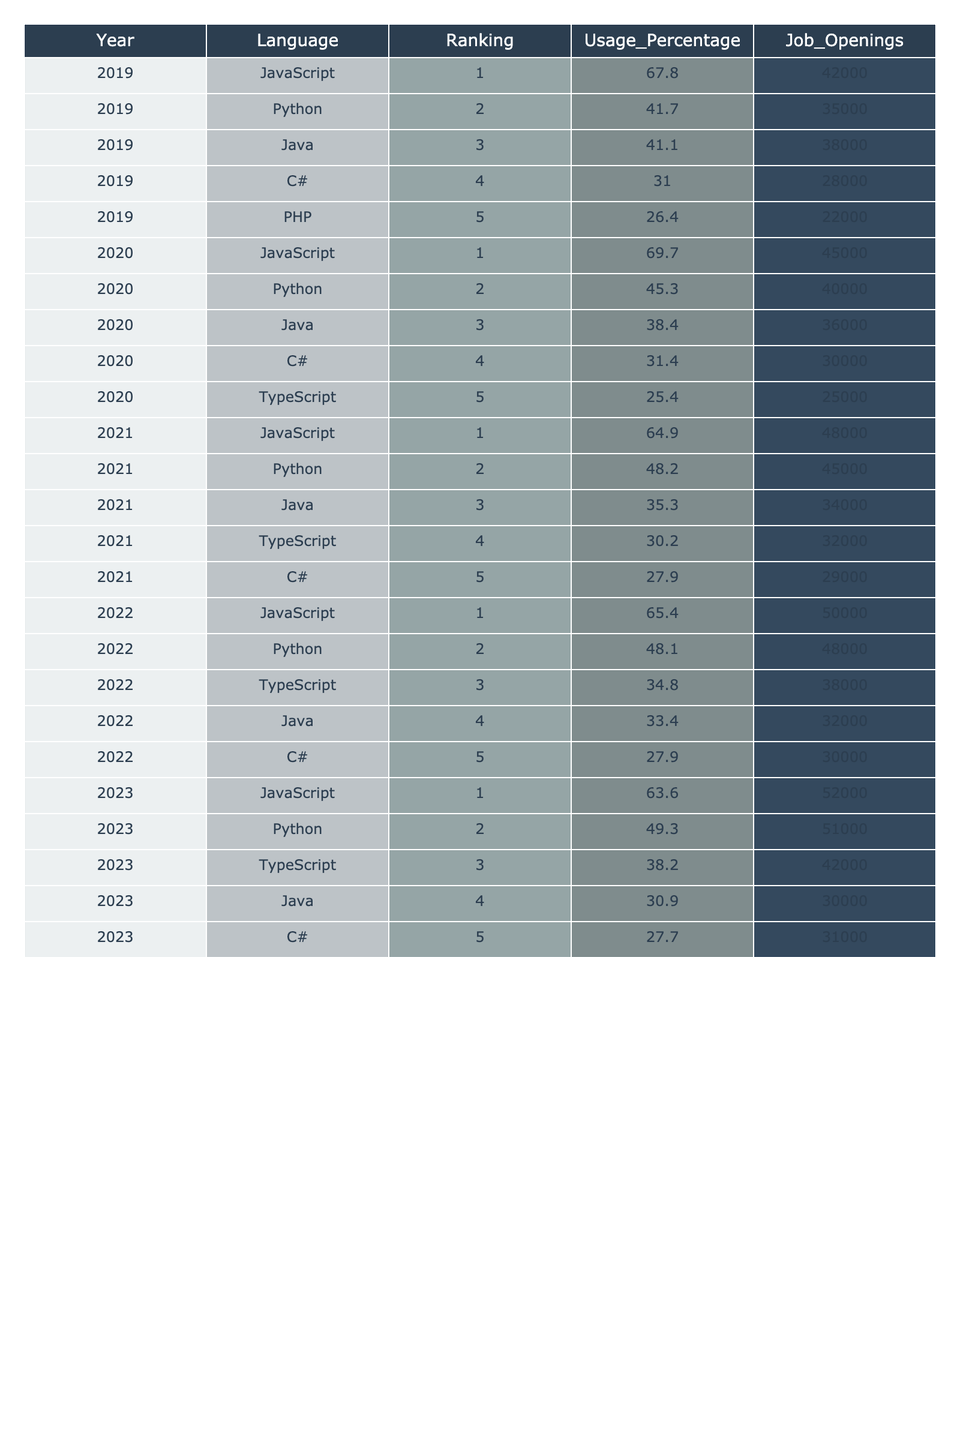What language had the highest usage percentage in 2023? In 2023, JavaScript had a usage percentage of 63.6%, which is higher than the other languages listed for that year.
Answer: JavaScript What is the ranking of TypeScript in 2021? In 2021, TypeScript was ranked 4th among the programming languages.
Answer: 4th Which language saw the most job openings in 2020? In 2020, JavaScript had the most job openings at 45,000, compared to other languages in the same year.
Answer: JavaScript What is the average job openings for Python over the past 5 years? The job openings for Python from 2019 to 2023 are 35,000, 40,000, 45,000, 48,000, and 51,000. Adding them gives 219,000, and dividing by 5 yields an average of 43,800.
Answer: 43,800 Did the ranking of PHP improve or decline from 2019 to 2023? PHP was ranked 5th in 2019 and was not listed in 2023, indicating a decline in its ranking.
Answer: Decline What was the percentage change in usage for Java from 2020 to 2023? In 2020, Java had a usage percentage of 38.4%, and in 2023 it was 30.9%. The percentage change is (30.9 - 38.4) / 38.4 * 100, which equals approximately -19.5%.
Answer: -19.5% Which programming language consistently held the 1st place ranking over the five years? JavaScript maintained the 1st place ranking for all five years from 2019 to 2023.
Answer: JavaScript What is the total job openings for C# from 2019 to 2022? The job openings for C# during these years are 28,000 (2019), 30,000 (2020), 29,000 (2021), and 30,000 (2022). Summing these yields 28,000 + 30,000 + 29,000 + 30,000 = 117,000.
Answer: 117,000 In which year did Python have the highest ranking? Python never ranked 1st in any year; it consistently ranked 2nd, which is the highest position it achieved during these years.
Answer: 2nd Which language had the least usage percentage in 2022? In 2022, C# had the least usage percentage at 27.9%, which is lower than all other languages for that year.
Answer: C# What was the trend of JavaScript's usage percentage from 2019 to 2023? JavaScript's usage percentages were 67.8% in 2019, 69.7% in 2020, but then decreased to 64.9% (2021), 65.4% (2022), and 63.6% (2023), showing a general downward trend after 2020.
Answer: Downward trend 